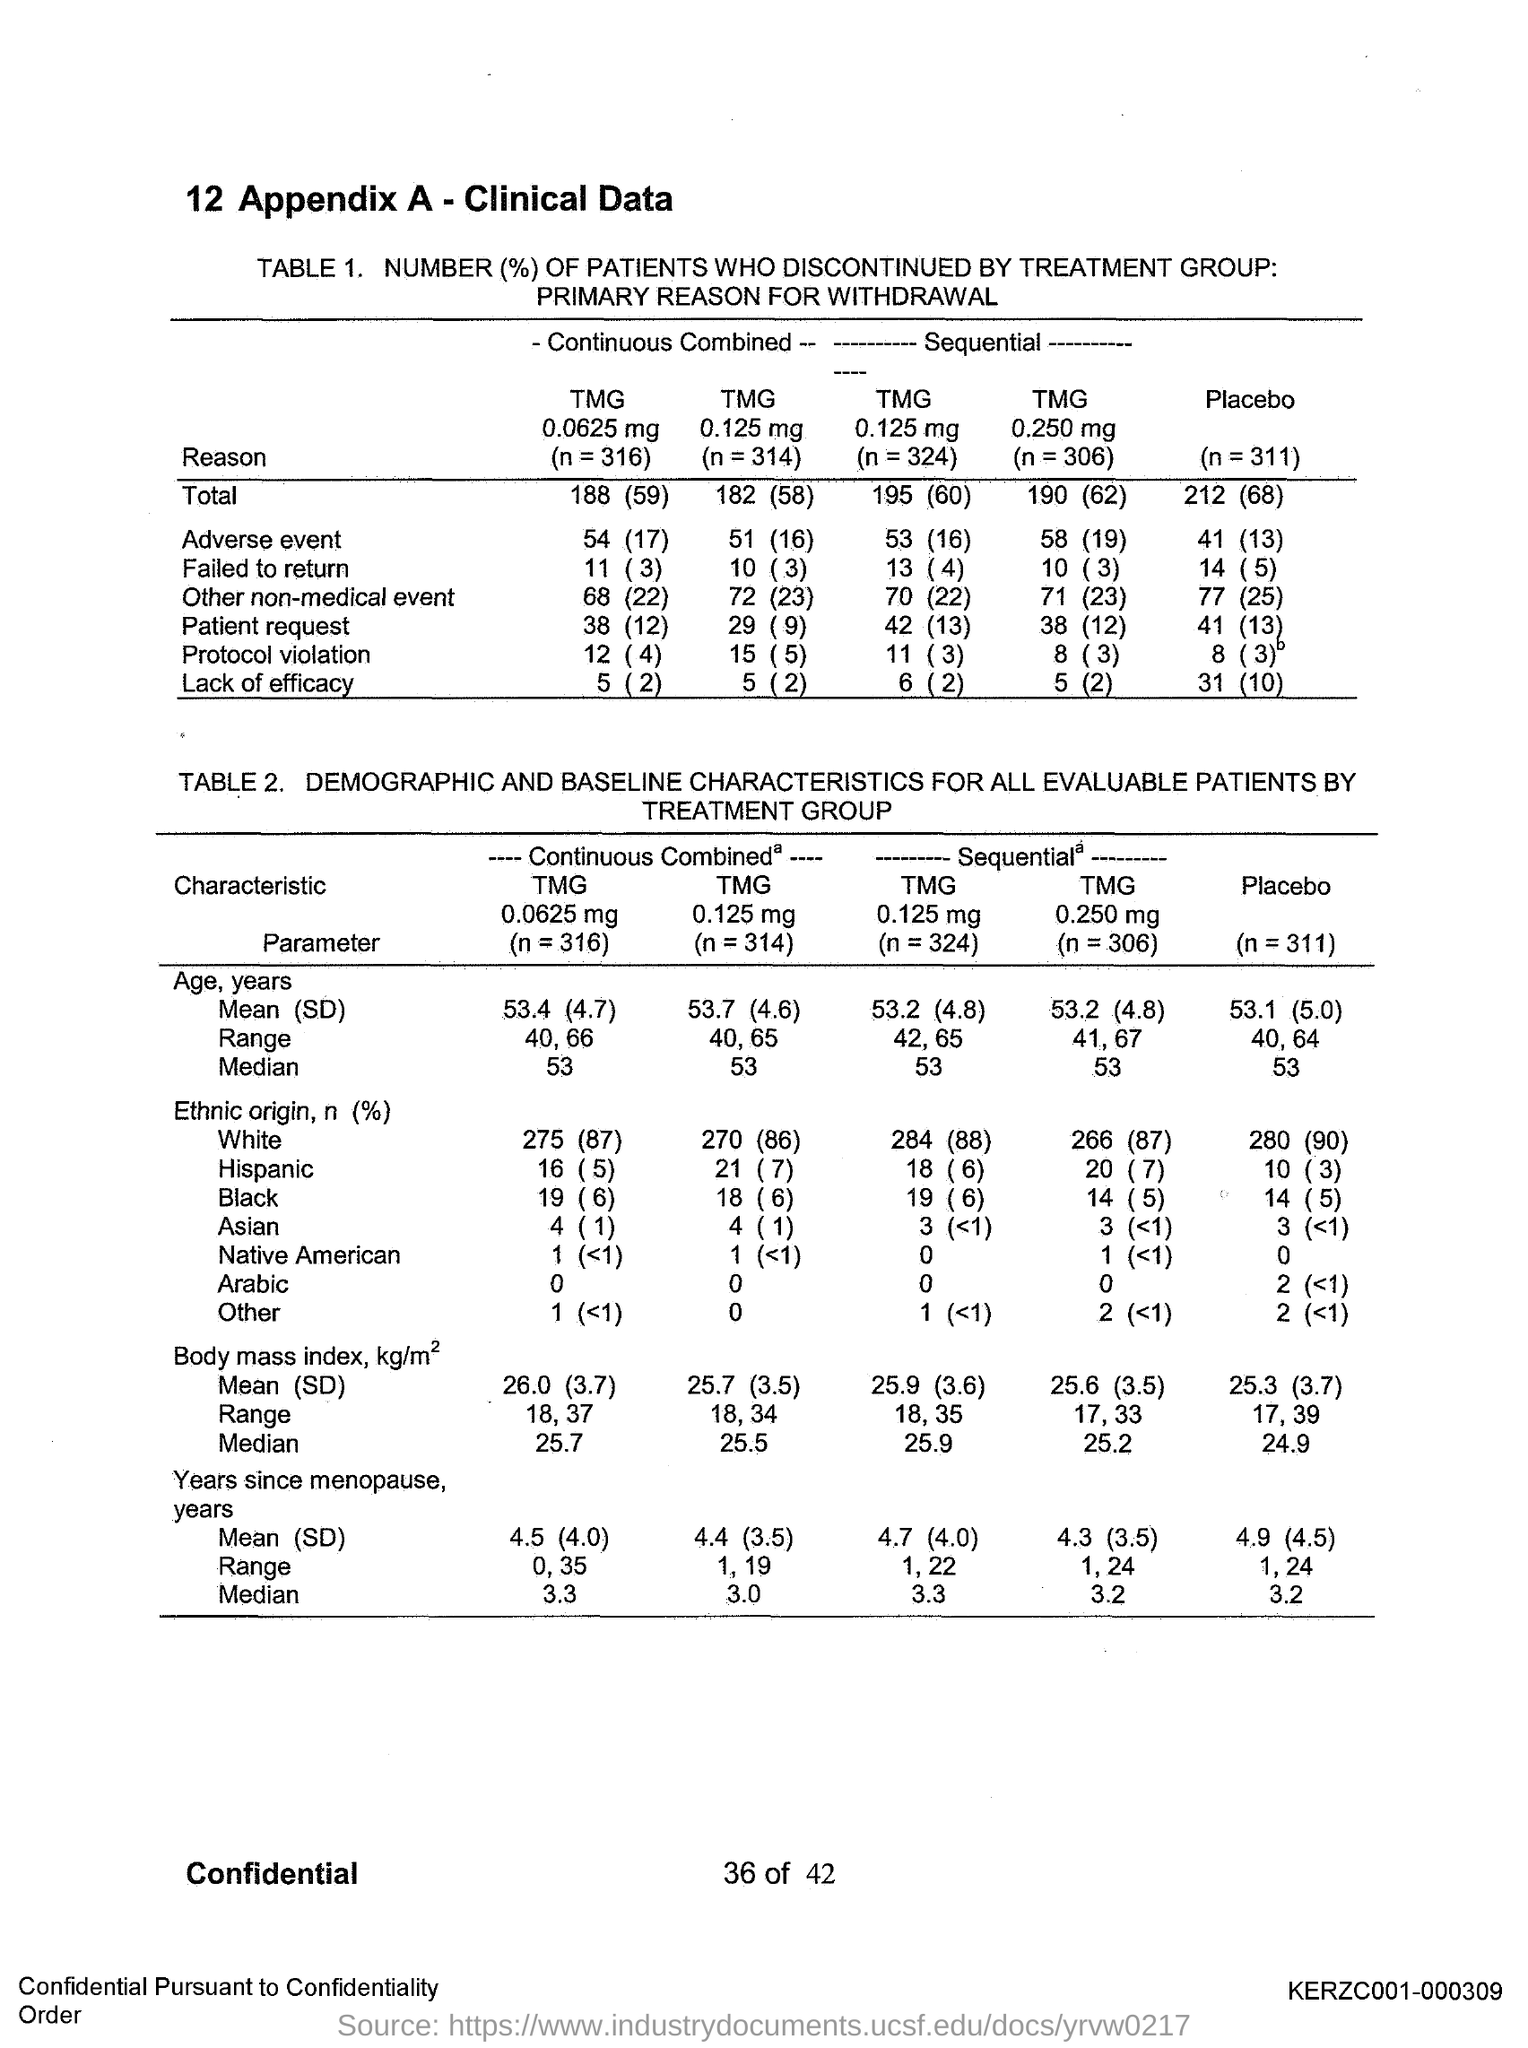What is the value of n for placebo?
Provide a succinct answer. N = 311. 